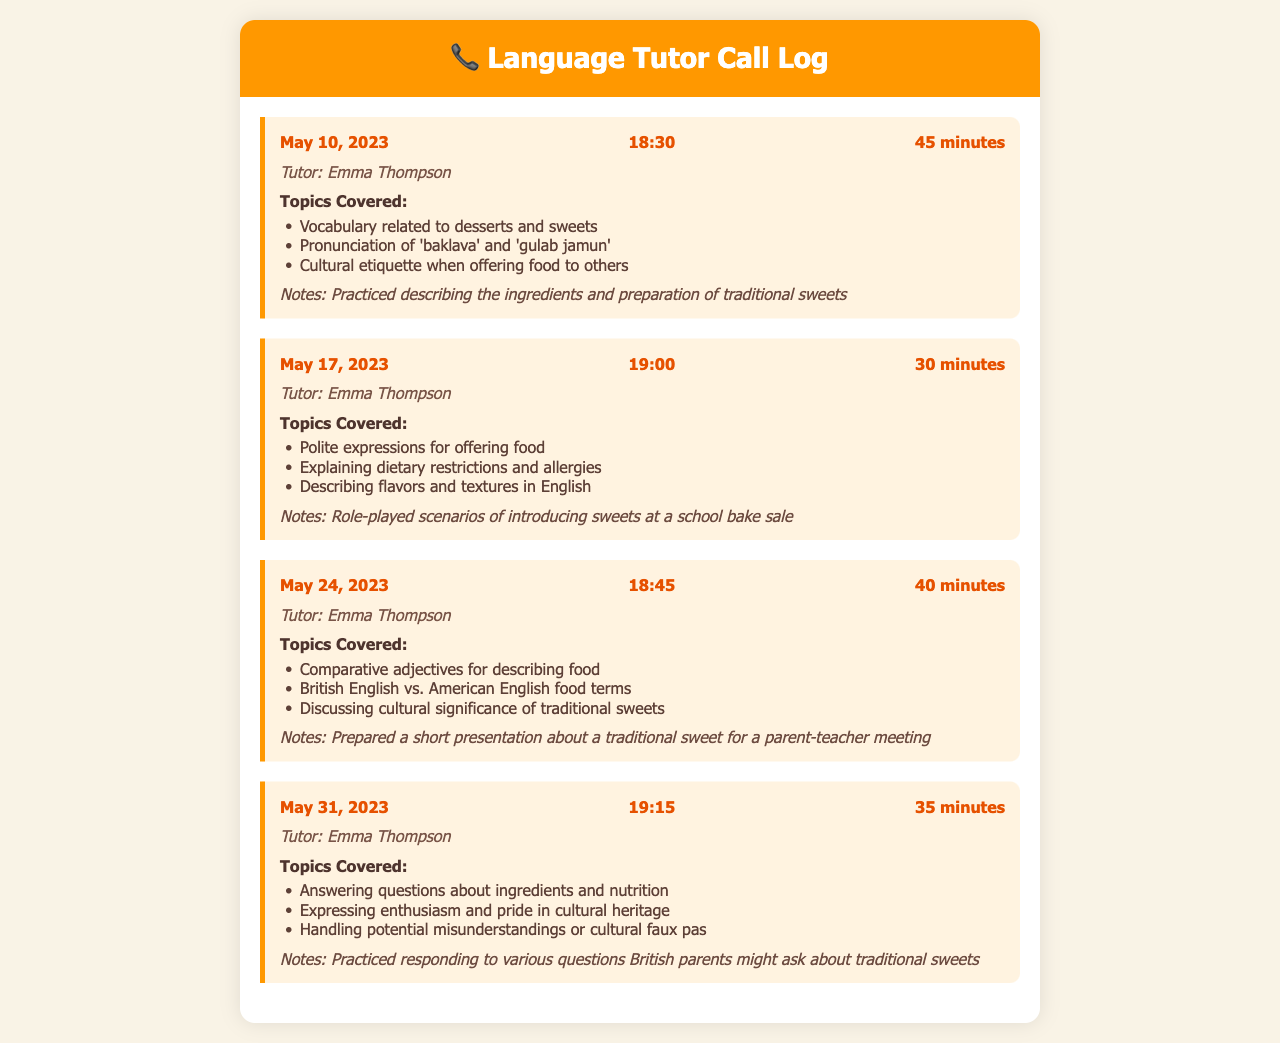What is the name of the tutor? The tutor's name is provided in each call entry under the "Tutor" label.
Answer: Emma Thompson How long was the call on May 24, 2023? The duration of each call is specified in the document, noted next to the call date and time.
Answer: 40 minutes What topic was covered in the call on May 31, 2023, regarding cultural heritage? The topics covered are listed within each call entry, and they include specific themes discussed during the conversation.
Answer: Expressing enthusiasm and pride in cultural heritage How many calls were logged in total? The number of call entries indicates how many conversations took place, as shown in the document’s structure.
Answer: 4 What was one of the topics discussed related to food in the call on May 17, 2023? Each call entry details specific topics, allowing for the identification of themes related to food discussed during the selected date.
Answer: Explaining dietary restrictions and allergies Which date included vocabulary related to desserts? Each call entry includes a date, allowing us to identify when certain topics were covered during each respective call.
Answer: May 10, 2023 What kind of role-play scenarios were practiced on May 17, 2023? The notes mention specific types of exercises or practice scenarios that were conducted during calls.
Answer: Introducing sweets at a school bake sale What color scheme is used in the document? The document's visual elements can be inferred through its descriptions, including background and text colors.
Answer: Warm tones 